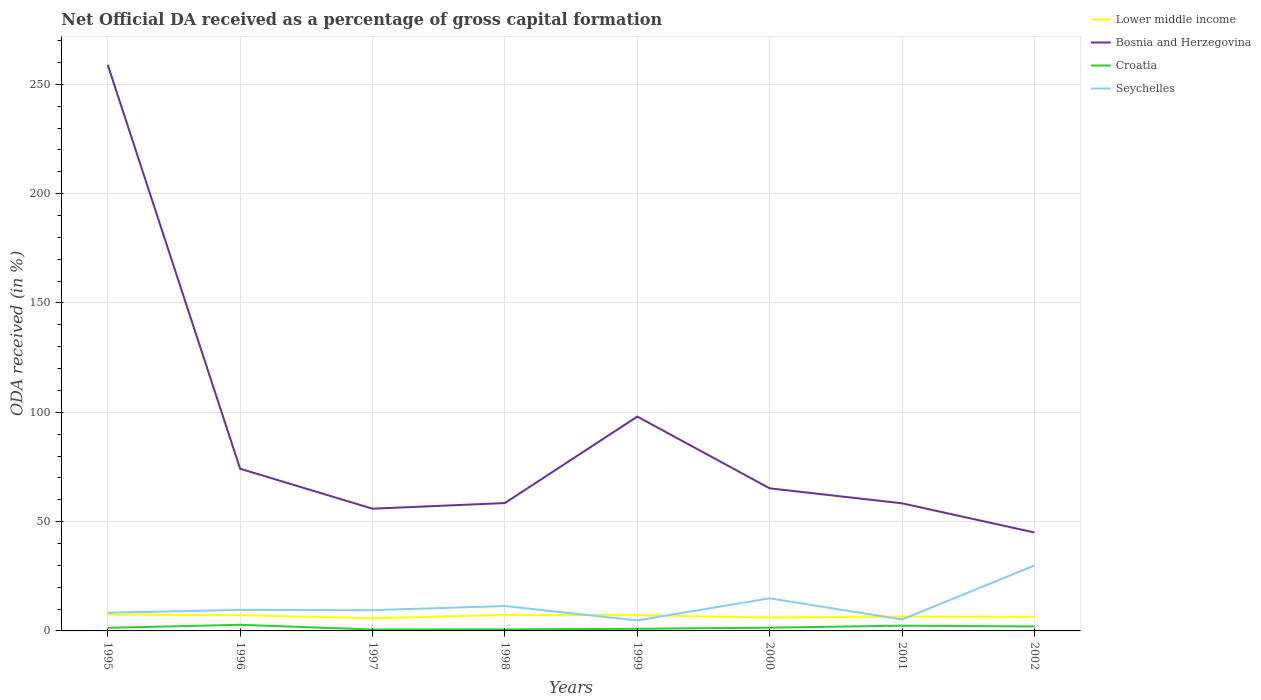Does the line corresponding to Croatia intersect with the line corresponding to Lower middle income?
Offer a terse response. No. Across all years, what is the maximum net ODA received in Bosnia and Herzegovina?
Offer a very short reply. 45.02. What is the total net ODA received in Seychelles in the graph?
Offer a very short reply. -24.7. What is the difference between the highest and the second highest net ODA received in Seychelles?
Keep it short and to the point. 25.13. What is the difference between the highest and the lowest net ODA received in Bosnia and Herzegovina?
Your answer should be very brief. 2. Is the net ODA received in Lower middle income strictly greater than the net ODA received in Seychelles over the years?
Give a very brief answer. No. Does the graph contain any zero values?
Ensure brevity in your answer.  No. Does the graph contain grids?
Provide a short and direct response. Yes. What is the title of the graph?
Provide a short and direct response. Net Official DA received as a percentage of gross capital formation. What is the label or title of the X-axis?
Make the answer very short. Years. What is the label or title of the Y-axis?
Make the answer very short. ODA received (in %). What is the ODA received (in %) of Lower middle income in 1995?
Provide a succinct answer. 7.51. What is the ODA received (in %) of Bosnia and Herzegovina in 1995?
Your response must be concise. 258.93. What is the ODA received (in %) in Croatia in 1995?
Ensure brevity in your answer.  1.41. What is the ODA received (in %) in Seychelles in 1995?
Your answer should be very brief. 8.32. What is the ODA received (in %) of Lower middle income in 1996?
Provide a succinct answer. 7.18. What is the ODA received (in %) in Bosnia and Herzegovina in 1996?
Offer a terse response. 74.18. What is the ODA received (in %) of Croatia in 1996?
Keep it short and to the point. 2.8. What is the ODA received (in %) of Seychelles in 1996?
Provide a short and direct response. 9.61. What is the ODA received (in %) in Lower middle income in 1997?
Provide a short and direct response. 5.78. What is the ODA received (in %) in Bosnia and Herzegovina in 1997?
Ensure brevity in your answer.  55.9. What is the ODA received (in %) in Croatia in 1997?
Give a very brief answer. 0.66. What is the ODA received (in %) of Seychelles in 1997?
Your answer should be very brief. 9.49. What is the ODA received (in %) of Lower middle income in 1998?
Offer a very short reply. 7.34. What is the ODA received (in %) in Bosnia and Herzegovina in 1998?
Provide a succinct answer. 58.49. What is the ODA received (in %) in Croatia in 1998?
Offer a very short reply. 0.72. What is the ODA received (in %) in Seychelles in 1998?
Your response must be concise. 11.38. What is the ODA received (in %) in Lower middle income in 1999?
Make the answer very short. 7.22. What is the ODA received (in %) of Bosnia and Herzegovina in 1999?
Offer a terse response. 98.04. What is the ODA received (in %) of Croatia in 1999?
Keep it short and to the point. 0.97. What is the ODA received (in %) of Seychelles in 1999?
Provide a short and direct response. 4.8. What is the ODA received (in %) of Lower middle income in 2000?
Your answer should be compact. 6.13. What is the ODA received (in %) of Bosnia and Herzegovina in 2000?
Your answer should be compact. 65.21. What is the ODA received (in %) in Croatia in 2000?
Keep it short and to the point. 1.49. What is the ODA received (in %) of Seychelles in 2000?
Offer a very short reply. 14.92. What is the ODA received (in %) of Lower middle income in 2001?
Offer a very short reply. 6.58. What is the ODA received (in %) of Bosnia and Herzegovina in 2001?
Ensure brevity in your answer.  58.36. What is the ODA received (in %) of Croatia in 2001?
Provide a short and direct response. 2.4. What is the ODA received (in %) of Seychelles in 2001?
Offer a very short reply. 5.23. What is the ODA received (in %) of Lower middle income in 2002?
Your answer should be compact. 6.42. What is the ODA received (in %) of Bosnia and Herzegovina in 2002?
Your response must be concise. 45.02. What is the ODA received (in %) of Croatia in 2002?
Keep it short and to the point. 2.05. What is the ODA received (in %) of Seychelles in 2002?
Your answer should be very brief. 29.92. Across all years, what is the maximum ODA received (in %) of Lower middle income?
Provide a short and direct response. 7.51. Across all years, what is the maximum ODA received (in %) in Bosnia and Herzegovina?
Provide a short and direct response. 258.93. Across all years, what is the maximum ODA received (in %) in Croatia?
Provide a short and direct response. 2.8. Across all years, what is the maximum ODA received (in %) in Seychelles?
Keep it short and to the point. 29.92. Across all years, what is the minimum ODA received (in %) in Lower middle income?
Offer a very short reply. 5.78. Across all years, what is the minimum ODA received (in %) of Bosnia and Herzegovina?
Offer a very short reply. 45.02. Across all years, what is the minimum ODA received (in %) in Croatia?
Your response must be concise. 0.66. Across all years, what is the minimum ODA received (in %) of Seychelles?
Keep it short and to the point. 4.8. What is the total ODA received (in %) in Lower middle income in the graph?
Provide a succinct answer. 54.15. What is the total ODA received (in %) in Bosnia and Herzegovina in the graph?
Give a very brief answer. 714.13. What is the total ODA received (in %) of Croatia in the graph?
Offer a terse response. 12.52. What is the total ODA received (in %) in Seychelles in the graph?
Your response must be concise. 93.67. What is the difference between the ODA received (in %) of Lower middle income in 1995 and that in 1996?
Ensure brevity in your answer.  0.32. What is the difference between the ODA received (in %) in Bosnia and Herzegovina in 1995 and that in 1996?
Your answer should be very brief. 184.74. What is the difference between the ODA received (in %) of Croatia in 1995 and that in 1996?
Your response must be concise. -1.39. What is the difference between the ODA received (in %) of Seychelles in 1995 and that in 1996?
Keep it short and to the point. -1.29. What is the difference between the ODA received (in %) of Lower middle income in 1995 and that in 1997?
Your response must be concise. 1.73. What is the difference between the ODA received (in %) in Bosnia and Herzegovina in 1995 and that in 1997?
Offer a very short reply. 203.03. What is the difference between the ODA received (in %) of Croatia in 1995 and that in 1997?
Give a very brief answer. 0.75. What is the difference between the ODA received (in %) of Seychelles in 1995 and that in 1997?
Your answer should be very brief. -1.17. What is the difference between the ODA received (in %) of Lower middle income in 1995 and that in 1998?
Ensure brevity in your answer.  0.17. What is the difference between the ODA received (in %) in Bosnia and Herzegovina in 1995 and that in 1998?
Ensure brevity in your answer.  200.44. What is the difference between the ODA received (in %) of Croatia in 1995 and that in 1998?
Keep it short and to the point. 0.7. What is the difference between the ODA received (in %) of Seychelles in 1995 and that in 1998?
Ensure brevity in your answer.  -3.06. What is the difference between the ODA received (in %) of Lower middle income in 1995 and that in 1999?
Provide a short and direct response. 0.29. What is the difference between the ODA received (in %) in Bosnia and Herzegovina in 1995 and that in 1999?
Your response must be concise. 160.89. What is the difference between the ODA received (in %) in Croatia in 1995 and that in 1999?
Offer a terse response. 0.44. What is the difference between the ODA received (in %) of Seychelles in 1995 and that in 1999?
Your answer should be very brief. 3.53. What is the difference between the ODA received (in %) of Lower middle income in 1995 and that in 2000?
Your answer should be compact. 1.38. What is the difference between the ODA received (in %) in Bosnia and Herzegovina in 1995 and that in 2000?
Make the answer very short. 193.71. What is the difference between the ODA received (in %) in Croatia in 1995 and that in 2000?
Make the answer very short. -0.08. What is the difference between the ODA received (in %) in Seychelles in 1995 and that in 2000?
Offer a terse response. -6.6. What is the difference between the ODA received (in %) in Lower middle income in 1995 and that in 2001?
Your response must be concise. 0.92. What is the difference between the ODA received (in %) in Bosnia and Herzegovina in 1995 and that in 2001?
Provide a short and direct response. 200.57. What is the difference between the ODA received (in %) in Croatia in 1995 and that in 2001?
Ensure brevity in your answer.  -0.99. What is the difference between the ODA received (in %) in Seychelles in 1995 and that in 2001?
Offer a very short reply. 3.09. What is the difference between the ODA received (in %) of Lower middle income in 1995 and that in 2002?
Keep it short and to the point. 1.09. What is the difference between the ODA received (in %) of Bosnia and Herzegovina in 1995 and that in 2002?
Ensure brevity in your answer.  213.91. What is the difference between the ODA received (in %) of Croatia in 1995 and that in 2002?
Provide a succinct answer. -0.64. What is the difference between the ODA received (in %) of Seychelles in 1995 and that in 2002?
Provide a short and direct response. -21.6. What is the difference between the ODA received (in %) in Lower middle income in 1996 and that in 1997?
Make the answer very short. 1.41. What is the difference between the ODA received (in %) in Bosnia and Herzegovina in 1996 and that in 1997?
Your response must be concise. 18.29. What is the difference between the ODA received (in %) in Croatia in 1996 and that in 1997?
Keep it short and to the point. 2.14. What is the difference between the ODA received (in %) in Seychelles in 1996 and that in 1997?
Make the answer very short. 0.12. What is the difference between the ODA received (in %) in Lower middle income in 1996 and that in 1998?
Ensure brevity in your answer.  -0.16. What is the difference between the ODA received (in %) of Bosnia and Herzegovina in 1996 and that in 1998?
Your answer should be compact. 15.7. What is the difference between the ODA received (in %) in Croatia in 1996 and that in 1998?
Provide a succinct answer. 2.08. What is the difference between the ODA received (in %) of Seychelles in 1996 and that in 1998?
Make the answer very short. -1.77. What is the difference between the ODA received (in %) in Lower middle income in 1996 and that in 1999?
Your answer should be very brief. -0.04. What is the difference between the ODA received (in %) of Bosnia and Herzegovina in 1996 and that in 1999?
Provide a short and direct response. -23.85. What is the difference between the ODA received (in %) in Croatia in 1996 and that in 1999?
Provide a short and direct response. 1.83. What is the difference between the ODA received (in %) of Seychelles in 1996 and that in 1999?
Make the answer very short. 4.82. What is the difference between the ODA received (in %) in Lower middle income in 1996 and that in 2000?
Keep it short and to the point. 1.05. What is the difference between the ODA received (in %) in Bosnia and Herzegovina in 1996 and that in 2000?
Your answer should be very brief. 8.97. What is the difference between the ODA received (in %) in Croatia in 1996 and that in 2000?
Give a very brief answer. 1.31. What is the difference between the ODA received (in %) of Seychelles in 1996 and that in 2000?
Offer a terse response. -5.31. What is the difference between the ODA received (in %) of Lower middle income in 1996 and that in 2001?
Ensure brevity in your answer.  0.6. What is the difference between the ODA received (in %) in Bosnia and Herzegovina in 1996 and that in 2001?
Make the answer very short. 15.82. What is the difference between the ODA received (in %) of Croatia in 1996 and that in 2001?
Your answer should be very brief. 0.4. What is the difference between the ODA received (in %) in Seychelles in 1996 and that in 2001?
Your answer should be compact. 4.38. What is the difference between the ODA received (in %) in Lower middle income in 1996 and that in 2002?
Your answer should be compact. 0.76. What is the difference between the ODA received (in %) of Bosnia and Herzegovina in 1996 and that in 2002?
Make the answer very short. 29.16. What is the difference between the ODA received (in %) of Croatia in 1996 and that in 2002?
Provide a short and direct response. 0.75. What is the difference between the ODA received (in %) of Seychelles in 1996 and that in 2002?
Offer a very short reply. -20.31. What is the difference between the ODA received (in %) in Lower middle income in 1997 and that in 1998?
Your answer should be compact. -1.56. What is the difference between the ODA received (in %) in Bosnia and Herzegovina in 1997 and that in 1998?
Offer a terse response. -2.59. What is the difference between the ODA received (in %) of Croatia in 1997 and that in 1998?
Make the answer very short. -0.06. What is the difference between the ODA received (in %) of Seychelles in 1997 and that in 1998?
Provide a short and direct response. -1.89. What is the difference between the ODA received (in %) in Lower middle income in 1997 and that in 1999?
Give a very brief answer. -1.44. What is the difference between the ODA received (in %) in Bosnia and Herzegovina in 1997 and that in 1999?
Your response must be concise. -42.14. What is the difference between the ODA received (in %) in Croatia in 1997 and that in 1999?
Ensure brevity in your answer.  -0.31. What is the difference between the ODA received (in %) in Seychelles in 1997 and that in 1999?
Keep it short and to the point. 4.7. What is the difference between the ODA received (in %) of Lower middle income in 1997 and that in 2000?
Your answer should be very brief. -0.35. What is the difference between the ODA received (in %) in Bosnia and Herzegovina in 1997 and that in 2000?
Offer a terse response. -9.32. What is the difference between the ODA received (in %) in Croatia in 1997 and that in 2000?
Give a very brief answer. -0.83. What is the difference between the ODA received (in %) in Seychelles in 1997 and that in 2000?
Ensure brevity in your answer.  -5.43. What is the difference between the ODA received (in %) of Lower middle income in 1997 and that in 2001?
Offer a very short reply. -0.81. What is the difference between the ODA received (in %) in Bosnia and Herzegovina in 1997 and that in 2001?
Your answer should be very brief. -2.46. What is the difference between the ODA received (in %) of Croatia in 1997 and that in 2001?
Make the answer very short. -1.74. What is the difference between the ODA received (in %) of Seychelles in 1997 and that in 2001?
Your answer should be compact. 4.26. What is the difference between the ODA received (in %) in Lower middle income in 1997 and that in 2002?
Give a very brief answer. -0.64. What is the difference between the ODA received (in %) in Bosnia and Herzegovina in 1997 and that in 2002?
Give a very brief answer. 10.88. What is the difference between the ODA received (in %) of Croatia in 1997 and that in 2002?
Ensure brevity in your answer.  -1.39. What is the difference between the ODA received (in %) of Seychelles in 1997 and that in 2002?
Keep it short and to the point. -20.43. What is the difference between the ODA received (in %) of Lower middle income in 1998 and that in 1999?
Provide a succinct answer. 0.12. What is the difference between the ODA received (in %) of Bosnia and Herzegovina in 1998 and that in 1999?
Provide a short and direct response. -39.55. What is the difference between the ODA received (in %) of Croatia in 1998 and that in 1999?
Ensure brevity in your answer.  -0.26. What is the difference between the ODA received (in %) of Seychelles in 1998 and that in 1999?
Ensure brevity in your answer.  6.59. What is the difference between the ODA received (in %) of Lower middle income in 1998 and that in 2000?
Provide a short and direct response. 1.21. What is the difference between the ODA received (in %) of Bosnia and Herzegovina in 1998 and that in 2000?
Your answer should be compact. -6.73. What is the difference between the ODA received (in %) of Croatia in 1998 and that in 2000?
Your answer should be very brief. -0.78. What is the difference between the ODA received (in %) of Seychelles in 1998 and that in 2000?
Give a very brief answer. -3.54. What is the difference between the ODA received (in %) in Lower middle income in 1998 and that in 2001?
Provide a succinct answer. 0.76. What is the difference between the ODA received (in %) of Bosnia and Herzegovina in 1998 and that in 2001?
Offer a terse response. 0.13. What is the difference between the ODA received (in %) of Croatia in 1998 and that in 2001?
Offer a terse response. -1.69. What is the difference between the ODA received (in %) of Seychelles in 1998 and that in 2001?
Keep it short and to the point. 6.15. What is the difference between the ODA received (in %) in Lower middle income in 1998 and that in 2002?
Give a very brief answer. 0.92. What is the difference between the ODA received (in %) in Bosnia and Herzegovina in 1998 and that in 2002?
Your answer should be very brief. 13.47. What is the difference between the ODA received (in %) of Croatia in 1998 and that in 2002?
Your answer should be very brief. -1.34. What is the difference between the ODA received (in %) of Seychelles in 1998 and that in 2002?
Give a very brief answer. -18.54. What is the difference between the ODA received (in %) of Lower middle income in 1999 and that in 2000?
Your answer should be compact. 1.09. What is the difference between the ODA received (in %) in Bosnia and Herzegovina in 1999 and that in 2000?
Provide a short and direct response. 32.82. What is the difference between the ODA received (in %) in Croatia in 1999 and that in 2000?
Your answer should be compact. -0.52. What is the difference between the ODA received (in %) in Seychelles in 1999 and that in 2000?
Provide a succinct answer. -10.12. What is the difference between the ODA received (in %) of Lower middle income in 1999 and that in 2001?
Your answer should be compact. 0.64. What is the difference between the ODA received (in %) in Bosnia and Herzegovina in 1999 and that in 2001?
Your answer should be compact. 39.68. What is the difference between the ODA received (in %) in Croatia in 1999 and that in 2001?
Provide a short and direct response. -1.43. What is the difference between the ODA received (in %) of Seychelles in 1999 and that in 2001?
Your answer should be compact. -0.43. What is the difference between the ODA received (in %) of Lower middle income in 1999 and that in 2002?
Offer a very short reply. 0.8. What is the difference between the ODA received (in %) in Bosnia and Herzegovina in 1999 and that in 2002?
Your response must be concise. 53.01. What is the difference between the ODA received (in %) in Croatia in 1999 and that in 2002?
Provide a short and direct response. -1.08. What is the difference between the ODA received (in %) in Seychelles in 1999 and that in 2002?
Give a very brief answer. -25.13. What is the difference between the ODA received (in %) of Lower middle income in 2000 and that in 2001?
Your answer should be very brief. -0.45. What is the difference between the ODA received (in %) of Bosnia and Herzegovina in 2000 and that in 2001?
Your response must be concise. 6.85. What is the difference between the ODA received (in %) of Croatia in 2000 and that in 2001?
Your response must be concise. -0.91. What is the difference between the ODA received (in %) in Seychelles in 2000 and that in 2001?
Offer a very short reply. 9.69. What is the difference between the ODA received (in %) of Lower middle income in 2000 and that in 2002?
Your answer should be compact. -0.29. What is the difference between the ODA received (in %) in Bosnia and Herzegovina in 2000 and that in 2002?
Give a very brief answer. 20.19. What is the difference between the ODA received (in %) in Croatia in 2000 and that in 2002?
Your response must be concise. -0.56. What is the difference between the ODA received (in %) in Seychelles in 2000 and that in 2002?
Offer a terse response. -15.01. What is the difference between the ODA received (in %) of Lower middle income in 2001 and that in 2002?
Give a very brief answer. 0.16. What is the difference between the ODA received (in %) in Bosnia and Herzegovina in 2001 and that in 2002?
Make the answer very short. 13.34. What is the difference between the ODA received (in %) in Croatia in 2001 and that in 2002?
Offer a very short reply. 0.35. What is the difference between the ODA received (in %) of Seychelles in 2001 and that in 2002?
Your answer should be compact. -24.7. What is the difference between the ODA received (in %) of Lower middle income in 1995 and the ODA received (in %) of Bosnia and Herzegovina in 1996?
Provide a succinct answer. -66.68. What is the difference between the ODA received (in %) in Lower middle income in 1995 and the ODA received (in %) in Croatia in 1996?
Give a very brief answer. 4.71. What is the difference between the ODA received (in %) of Lower middle income in 1995 and the ODA received (in %) of Seychelles in 1996?
Ensure brevity in your answer.  -2.11. What is the difference between the ODA received (in %) of Bosnia and Herzegovina in 1995 and the ODA received (in %) of Croatia in 1996?
Your response must be concise. 256.13. What is the difference between the ODA received (in %) of Bosnia and Herzegovina in 1995 and the ODA received (in %) of Seychelles in 1996?
Your answer should be very brief. 249.32. What is the difference between the ODA received (in %) in Croatia in 1995 and the ODA received (in %) in Seychelles in 1996?
Your answer should be very brief. -8.2. What is the difference between the ODA received (in %) of Lower middle income in 1995 and the ODA received (in %) of Bosnia and Herzegovina in 1997?
Ensure brevity in your answer.  -48.39. What is the difference between the ODA received (in %) in Lower middle income in 1995 and the ODA received (in %) in Croatia in 1997?
Offer a terse response. 6.85. What is the difference between the ODA received (in %) of Lower middle income in 1995 and the ODA received (in %) of Seychelles in 1997?
Your answer should be compact. -1.99. What is the difference between the ODA received (in %) of Bosnia and Herzegovina in 1995 and the ODA received (in %) of Croatia in 1997?
Your response must be concise. 258.27. What is the difference between the ODA received (in %) in Bosnia and Herzegovina in 1995 and the ODA received (in %) in Seychelles in 1997?
Provide a succinct answer. 249.44. What is the difference between the ODA received (in %) of Croatia in 1995 and the ODA received (in %) of Seychelles in 1997?
Keep it short and to the point. -8.08. What is the difference between the ODA received (in %) of Lower middle income in 1995 and the ODA received (in %) of Bosnia and Herzegovina in 1998?
Keep it short and to the point. -50.98. What is the difference between the ODA received (in %) in Lower middle income in 1995 and the ODA received (in %) in Croatia in 1998?
Offer a terse response. 6.79. What is the difference between the ODA received (in %) in Lower middle income in 1995 and the ODA received (in %) in Seychelles in 1998?
Provide a short and direct response. -3.87. What is the difference between the ODA received (in %) in Bosnia and Herzegovina in 1995 and the ODA received (in %) in Croatia in 1998?
Keep it short and to the point. 258.21. What is the difference between the ODA received (in %) of Bosnia and Herzegovina in 1995 and the ODA received (in %) of Seychelles in 1998?
Make the answer very short. 247.55. What is the difference between the ODA received (in %) of Croatia in 1995 and the ODA received (in %) of Seychelles in 1998?
Keep it short and to the point. -9.97. What is the difference between the ODA received (in %) of Lower middle income in 1995 and the ODA received (in %) of Bosnia and Herzegovina in 1999?
Make the answer very short. -90.53. What is the difference between the ODA received (in %) of Lower middle income in 1995 and the ODA received (in %) of Croatia in 1999?
Give a very brief answer. 6.53. What is the difference between the ODA received (in %) of Lower middle income in 1995 and the ODA received (in %) of Seychelles in 1999?
Make the answer very short. 2.71. What is the difference between the ODA received (in %) in Bosnia and Herzegovina in 1995 and the ODA received (in %) in Croatia in 1999?
Provide a succinct answer. 257.95. What is the difference between the ODA received (in %) of Bosnia and Herzegovina in 1995 and the ODA received (in %) of Seychelles in 1999?
Offer a terse response. 254.13. What is the difference between the ODA received (in %) of Croatia in 1995 and the ODA received (in %) of Seychelles in 1999?
Your answer should be compact. -3.38. What is the difference between the ODA received (in %) of Lower middle income in 1995 and the ODA received (in %) of Bosnia and Herzegovina in 2000?
Make the answer very short. -57.71. What is the difference between the ODA received (in %) in Lower middle income in 1995 and the ODA received (in %) in Croatia in 2000?
Offer a very short reply. 6.01. What is the difference between the ODA received (in %) in Lower middle income in 1995 and the ODA received (in %) in Seychelles in 2000?
Ensure brevity in your answer.  -7.41. What is the difference between the ODA received (in %) in Bosnia and Herzegovina in 1995 and the ODA received (in %) in Croatia in 2000?
Your answer should be very brief. 257.43. What is the difference between the ODA received (in %) in Bosnia and Herzegovina in 1995 and the ODA received (in %) in Seychelles in 2000?
Keep it short and to the point. 244.01. What is the difference between the ODA received (in %) in Croatia in 1995 and the ODA received (in %) in Seychelles in 2000?
Ensure brevity in your answer.  -13.51. What is the difference between the ODA received (in %) of Lower middle income in 1995 and the ODA received (in %) of Bosnia and Herzegovina in 2001?
Your answer should be compact. -50.85. What is the difference between the ODA received (in %) in Lower middle income in 1995 and the ODA received (in %) in Croatia in 2001?
Your answer should be compact. 5.1. What is the difference between the ODA received (in %) in Lower middle income in 1995 and the ODA received (in %) in Seychelles in 2001?
Offer a terse response. 2.28. What is the difference between the ODA received (in %) in Bosnia and Herzegovina in 1995 and the ODA received (in %) in Croatia in 2001?
Your answer should be very brief. 256.52. What is the difference between the ODA received (in %) in Bosnia and Herzegovina in 1995 and the ODA received (in %) in Seychelles in 2001?
Your response must be concise. 253.7. What is the difference between the ODA received (in %) in Croatia in 1995 and the ODA received (in %) in Seychelles in 2001?
Provide a succinct answer. -3.82. What is the difference between the ODA received (in %) of Lower middle income in 1995 and the ODA received (in %) of Bosnia and Herzegovina in 2002?
Make the answer very short. -37.52. What is the difference between the ODA received (in %) of Lower middle income in 1995 and the ODA received (in %) of Croatia in 2002?
Your response must be concise. 5.45. What is the difference between the ODA received (in %) in Lower middle income in 1995 and the ODA received (in %) in Seychelles in 2002?
Your answer should be very brief. -22.42. What is the difference between the ODA received (in %) of Bosnia and Herzegovina in 1995 and the ODA received (in %) of Croatia in 2002?
Give a very brief answer. 256.87. What is the difference between the ODA received (in %) in Bosnia and Herzegovina in 1995 and the ODA received (in %) in Seychelles in 2002?
Offer a very short reply. 229. What is the difference between the ODA received (in %) of Croatia in 1995 and the ODA received (in %) of Seychelles in 2002?
Make the answer very short. -28.51. What is the difference between the ODA received (in %) of Lower middle income in 1996 and the ODA received (in %) of Bosnia and Herzegovina in 1997?
Your answer should be very brief. -48.72. What is the difference between the ODA received (in %) of Lower middle income in 1996 and the ODA received (in %) of Croatia in 1997?
Give a very brief answer. 6.52. What is the difference between the ODA received (in %) of Lower middle income in 1996 and the ODA received (in %) of Seychelles in 1997?
Give a very brief answer. -2.31. What is the difference between the ODA received (in %) of Bosnia and Herzegovina in 1996 and the ODA received (in %) of Croatia in 1997?
Your answer should be very brief. 73.52. What is the difference between the ODA received (in %) in Bosnia and Herzegovina in 1996 and the ODA received (in %) in Seychelles in 1997?
Provide a short and direct response. 64.69. What is the difference between the ODA received (in %) of Croatia in 1996 and the ODA received (in %) of Seychelles in 1997?
Provide a short and direct response. -6.69. What is the difference between the ODA received (in %) of Lower middle income in 1996 and the ODA received (in %) of Bosnia and Herzegovina in 1998?
Your answer should be very brief. -51.31. What is the difference between the ODA received (in %) in Lower middle income in 1996 and the ODA received (in %) in Croatia in 1998?
Offer a very short reply. 6.47. What is the difference between the ODA received (in %) in Lower middle income in 1996 and the ODA received (in %) in Seychelles in 1998?
Ensure brevity in your answer.  -4.2. What is the difference between the ODA received (in %) of Bosnia and Herzegovina in 1996 and the ODA received (in %) of Croatia in 1998?
Keep it short and to the point. 73.47. What is the difference between the ODA received (in %) of Bosnia and Herzegovina in 1996 and the ODA received (in %) of Seychelles in 1998?
Offer a terse response. 62.8. What is the difference between the ODA received (in %) of Croatia in 1996 and the ODA received (in %) of Seychelles in 1998?
Your answer should be very brief. -8.58. What is the difference between the ODA received (in %) in Lower middle income in 1996 and the ODA received (in %) in Bosnia and Herzegovina in 1999?
Provide a short and direct response. -90.85. What is the difference between the ODA received (in %) of Lower middle income in 1996 and the ODA received (in %) of Croatia in 1999?
Your response must be concise. 6.21. What is the difference between the ODA received (in %) in Lower middle income in 1996 and the ODA received (in %) in Seychelles in 1999?
Your response must be concise. 2.39. What is the difference between the ODA received (in %) of Bosnia and Herzegovina in 1996 and the ODA received (in %) of Croatia in 1999?
Provide a short and direct response. 73.21. What is the difference between the ODA received (in %) in Bosnia and Herzegovina in 1996 and the ODA received (in %) in Seychelles in 1999?
Provide a succinct answer. 69.39. What is the difference between the ODA received (in %) in Croatia in 1996 and the ODA received (in %) in Seychelles in 1999?
Provide a succinct answer. -2. What is the difference between the ODA received (in %) in Lower middle income in 1996 and the ODA received (in %) in Bosnia and Herzegovina in 2000?
Provide a succinct answer. -58.03. What is the difference between the ODA received (in %) of Lower middle income in 1996 and the ODA received (in %) of Croatia in 2000?
Your response must be concise. 5.69. What is the difference between the ODA received (in %) in Lower middle income in 1996 and the ODA received (in %) in Seychelles in 2000?
Your response must be concise. -7.74. What is the difference between the ODA received (in %) of Bosnia and Herzegovina in 1996 and the ODA received (in %) of Croatia in 2000?
Make the answer very short. 72.69. What is the difference between the ODA received (in %) in Bosnia and Herzegovina in 1996 and the ODA received (in %) in Seychelles in 2000?
Give a very brief answer. 59.27. What is the difference between the ODA received (in %) of Croatia in 1996 and the ODA received (in %) of Seychelles in 2000?
Your answer should be compact. -12.12. What is the difference between the ODA received (in %) in Lower middle income in 1996 and the ODA received (in %) in Bosnia and Herzegovina in 2001?
Offer a very short reply. -51.18. What is the difference between the ODA received (in %) in Lower middle income in 1996 and the ODA received (in %) in Croatia in 2001?
Keep it short and to the point. 4.78. What is the difference between the ODA received (in %) of Lower middle income in 1996 and the ODA received (in %) of Seychelles in 2001?
Provide a short and direct response. 1.95. What is the difference between the ODA received (in %) of Bosnia and Herzegovina in 1996 and the ODA received (in %) of Croatia in 2001?
Your response must be concise. 71.78. What is the difference between the ODA received (in %) of Bosnia and Herzegovina in 1996 and the ODA received (in %) of Seychelles in 2001?
Your response must be concise. 68.95. What is the difference between the ODA received (in %) in Croatia in 1996 and the ODA received (in %) in Seychelles in 2001?
Your answer should be compact. -2.43. What is the difference between the ODA received (in %) in Lower middle income in 1996 and the ODA received (in %) in Bosnia and Herzegovina in 2002?
Provide a succinct answer. -37.84. What is the difference between the ODA received (in %) of Lower middle income in 1996 and the ODA received (in %) of Croatia in 2002?
Provide a succinct answer. 5.13. What is the difference between the ODA received (in %) of Lower middle income in 1996 and the ODA received (in %) of Seychelles in 2002?
Offer a very short reply. -22.74. What is the difference between the ODA received (in %) in Bosnia and Herzegovina in 1996 and the ODA received (in %) in Croatia in 2002?
Ensure brevity in your answer.  72.13. What is the difference between the ODA received (in %) of Bosnia and Herzegovina in 1996 and the ODA received (in %) of Seychelles in 2002?
Provide a succinct answer. 44.26. What is the difference between the ODA received (in %) in Croatia in 1996 and the ODA received (in %) in Seychelles in 2002?
Offer a very short reply. -27.12. What is the difference between the ODA received (in %) of Lower middle income in 1997 and the ODA received (in %) of Bosnia and Herzegovina in 1998?
Ensure brevity in your answer.  -52.71. What is the difference between the ODA received (in %) of Lower middle income in 1997 and the ODA received (in %) of Croatia in 1998?
Make the answer very short. 5.06. What is the difference between the ODA received (in %) in Lower middle income in 1997 and the ODA received (in %) in Seychelles in 1998?
Offer a terse response. -5.6. What is the difference between the ODA received (in %) of Bosnia and Herzegovina in 1997 and the ODA received (in %) of Croatia in 1998?
Provide a short and direct response. 55.18. What is the difference between the ODA received (in %) of Bosnia and Herzegovina in 1997 and the ODA received (in %) of Seychelles in 1998?
Offer a very short reply. 44.52. What is the difference between the ODA received (in %) in Croatia in 1997 and the ODA received (in %) in Seychelles in 1998?
Provide a succinct answer. -10.72. What is the difference between the ODA received (in %) in Lower middle income in 1997 and the ODA received (in %) in Bosnia and Herzegovina in 1999?
Give a very brief answer. -92.26. What is the difference between the ODA received (in %) of Lower middle income in 1997 and the ODA received (in %) of Croatia in 1999?
Offer a terse response. 4.8. What is the difference between the ODA received (in %) of Lower middle income in 1997 and the ODA received (in %) of Seychelles in 1999?
Provide a succinct answer. 0.98. What is the difference between the ODA received (in %) in Bosnia and Herzegovina in 1997 and the ODA received (in %) in Croatia in 1999?
Offer a terse response. 54.92. What is the difference between the ODA received (in %) in Bosnia and Herzegovina in 1997 and the ODA received (in %) in Seychelles in 1999?
Provide a succinct answer. 51.1. What is the difference between the ODA received (in %) in Croatia in 1997 and the ODA received (in %) in Seychelles in 1999?
Your response must be concise. -4.13. What is the difference between the ODA received (in %) of Lower middle income in 1997 and the ODA received (in %) of Bosnia and Herzegovina in 2000?
Offer a terse response. -59.44. What is the difference between the ODA received (in %) of Lower middle income in 1997 and the ODA received (in %) of Croatia in 2000?
Offer a very short reply. 4.28. What is the difference between the ODA received (in %) of Lower middle income in 1997 and the ODA received (in %) of Seychelles in 2000?
Make the answer very short. -9.14. What is the difference between the ODA received (in %) of Bosnia and Herzegovina in 1997 and the ODA received (in %) of Croatia in 2000?
Offer a very short reply. 54.41. What is the difference between the ODA received (in %) in Bosnia and Herzegovina in 1997 and the ODA received (in %) in Seychelles in 2000?
Your answer should be very brief. 40.98. What is the difference between the ODA received (in %) of Croatia in 1997 and the ODA received (in %) of Seychelles in 2000?
Provide a succinct answer. -14.26. What is the difference between the ODA received (in %) in Lower middle income in 1997 and the ODA received (in %) in Bosnia and Herzegovina in 2001?
Provide a short and direct response. -52.58. What is the difference between the ODA received (in %) of Lower middle income in 1997 and the ODA received (in %) of Croatia in 2001?
Offer a terse response. 3.37. What is the difference between the ODA received (in %) of Lower middle income in 1997 and the ODA received (in %) of Seychelles in 2001?
Provide a short and direct response. 0.55. What is the difference between the ODA received (in %) in Bosnia and Herzegovina in 1997 and the ODA received (in %) in Croatia in 2001?
Your answer should be very brief. 53.49. What is the difference between the ODA received (in %) in Bosnia and Herzegovina in 1997 and the ODA received (in %) in Seychelles in 2001?
Ensure brevity in your answer.  50.67. What is the difference between the ODA received (in %) of Croatia in 1997 and the ODA received (in %) of Seychelles in 2001?
Give a very brief answer. -4.57. What is the difference between the ODA received (in %) in Lower middle income in 1997 and the ODA received (in %) in Bosnia and Herzegovina in 2002?
Provide a short and direct response. -39.25. What is the difference between the ODA received (in %) of Lower middle income in 1997 and the ODA received (in %) of Croatia in 2002?
Give a very brief answer. 3.72. What is the difference between the ODA received (in %) in Lower middle income in 1997 and the ODA received (in %) in Seychelles in 2002?
Keep it short and to the point. -24.15. What is the difference between the ODA received (in %) in Bosnia and Herzegovina in 1997 and the ODA received (in %) in Croatia in 2002?
Your answer should be compact. 53.84. What is the difference between the ODA received (in %) in Bosnia and Herzegovina in 1997 and the ODA received (in %) in Seychelles in 2002?
Offer a very short reply. 25.97. What is the difference between the ODA received (in %) in Croatia in 1997 and the ODA received (in %) in Seychelles in 2002?
Give a very brief answer. -29.26. What is the difference between the ODA received (in %) of Lower middle income in 1998 and the ODA received (in %) of Bosnia and Herzegovina in 1999?
Your response must be concise. -90.7. What is the difference between the ODA received (in %) in Lower middle income in 1998 and the ODA received (in %) in Croatia in 1999?
Provide a short and direct response. 6.36. What is the difference between the ODA received (in %) of Lower middle income in 1998 and the ODA received (in %) of Seychelles in 1999?
Provide a succinct answer. 2.54. What is the difference between the ODA received (in %) in Bosnia and Herzegovina in 1998 and the ODA received (in %) in Croatia in 1999?
Give a very brief answer. 57.51. What is the difference between the ODA received (in %) of Bosnia and Herzegovina in 1998 and the ODA received (in %) of Seychelles in 1999?
Keep it short and to the point. 53.69. What is the difference between the ODA received (in %) in Croatia in 1998 and the ODA received (in %) in Seychelles in 1999?
Give a very brief answer. -4.08. What is the difference between the ODA received (in %) in Lower middle income in 1998 and the ODA received (in %) in Bosnia and Herzegovina in 2000?
Provide a succinct answer. -57.88. What is the difference between the ODA received (in %) of Lower middle income in 1998 and the ODA received (in %) of Croatia in 2000?
Ensure brevity in your answer.  5.85. What is the difference between the ODA received (in %) of Lower middle income in 1998 and the ODA received (in %) of Seychelles in 2000?
Offer a terse response. -7.58. What is the difference between the ODA received (in %) in Bosnia and Herzegovina in 1998 and the ODA received (in %) in Croatia in 2000?
Ensure brevity in your answer.  57. What is the difference between the ODA received (in %) of Bosnia and Herzegovina in 1998 and the ODA received (in %) of Seychelles in 2000?
Ensure brevity in your answer.  43.57. What is the difference between the ODA received (in %) of Croatia in 1998 and the ODA received (in %) of Seychelles in 2000?
Provide a succinct answer. -14.2. What is the difference between the ODA received (in %) of Lower middle income in 1998 and the ODA received (in %) of Bosnia and Herzegovina in 2001?
Your answer should be compact. -51.02. What is the difference between the ODA received (in %) of Lower middle income in 1998 and the ODA received (in %) of Croatia in 2001?
Your answer should be very brief. 4.93. What is the difference between the ODA received (in %) of Lower middle income in 1998 and the ODA received (in %) of Seychelles in 2001?
Your answer should be very brief. 2.11. What is the difference between the ODA received (in %) of Bosnia and Herzegovina in 1998 and the ODA received (in %) of Croatia in 2001?
Keep it short and to the point. 56.08. What is the difference between the ODA received (in %) in Bosnia and Herzegovina in 1998 and the ODA received (in %) in Seychelles in 2001?
Your answer should be compact. 53.26. What is the difference between the ODA received (in %) of Croatia in 1998 and the ODA received (in %) of Seychelles in 2001?
Offer a terse response. -4.51. What is the difference between the ODA received (in %) in Lower middle income in 1998 and the ODA received (in %) in Bosnia and Herzegovina in 2002?
Provide a short and direct response. -37.68. What is the difference between the ODA received (in %) in Lower middle income in 1998 and the ODA received (in %) in Croatia in 2002?
Your response must be concise. 5.28. What is the difference between the ODA received (in %) of Lower middle income in 1998 and the ODA received (in %) of Seychelles in 2002?
Provide a succinct answer. -22.59. What is the difference between the ODA received (in %) in Bosnia and Herzegovina in 1998 and the ODA received (in %) in Croatia in 2002?
Make the answer very short. 56.44. What is the difference between the ODA received (in %) of Bosnia and Herzegovina in 1998 and the ODA received (in %) of Seychelles in 2002?
Your answer should be very brief. 28.56. What is the difference between the ODA received (in %) of Croatia in 1998 and the ODA received (in %) of Seychelles in 2002?
Ensure brevity in your answer.  -29.21. What is the difference between the ODA received (in %) in Lower middle income in 1999 and the ODA received (in %) in Bosnia and Herzegovina in 2000?
Provide a short and direct response. -58. What is the difference between the ODA received (in %) in Lower middle income in 1999 and the ODA received (in %) in Croatia in 2000?
Offer a very short reply. 5.73. What is the difference between the ODA received (in %) of Lower middle income in 1999 and the ODA received (in %) of Seychelles in 2000?
Offer a very short reply. -7.7. What is the difference between the ODA received (in %) in Bosnia and Herzegovina in 1999 and the ODA received (in %) in Croatia in 2000?
Offer a terse response. 96.54. What is the difference between the ODA received (in %) in Bosnia and Herzegovina in 1999 and the ODA received (in %) in Seychelles in 2000?
Make the answer very short. 83.12. What is the difference between the ODA received (in %) in Croatia in 1999 and the ODA received (in %) in Seychelles in 2000?
Ensure brevity in your answer.  -13.94. What is the difference between the ODA received (in %) in Lower middle income in 1999 and the ODA received (in %) in Bosnia and Herzegovina in 2001?
Your answer should be very brief. -51.14. What is the difference between the ODA received (in %) in Lower middle income in 1999 and the ODA received (in %) in Croatia in 2001?
Your answer should be compact. 4.81. What is the difference between the ODA received (in %) of Lower middle income in 1999 and the ODA received (in %) of Seychelles in 2001?
Make the answer very short. 1.99. What is the difference between the ODA received (in %) of Bosnia and Herzegovina in 1999 and the ODA received (in %) of Croatia in 2001?
Provide a short and direct response. 95.63. What is the difference between the ODA received (in %) in Bosnia and Herzegovina in 1999 and the ODA received (in %) in Seychelles in 2001?
Keep it short and to the point. 92.81. What is the difference between the ODA received (in %) in Croatia in 1999 and the ODA received (in %) in Seychelles in 2001?
Your answer should be very brief. -4.25. What is the difference between the ODA received (in %) in Lower middle income in 1999 and the ODA received (in %) in Bosnia and Herzegovina in 2002?
Your answer should be compact. -37.8. What is the difference between the ODA received (in %) in Lower middle income in 1999 and the ODA received (in %) in Croatia in 2002?
Provide a short and direct response. 5.16. What is the difference between the ODA received (in %) of Lower middle income in 1999 and the ODA received (in %) of Seychelles in 2002?
Give a very brief answer. -22.71. What is the difference between the ODA received (in %) in Bosnia and Herzegovina in 1999 and the ODA received (in %) in Croatia in 2002?
Give a very brief answer. 95.98. What is the difference between the ODA received (in %) of Bosnia and Herzegovina in 1999 and the ODA received (in %) of Seychelles in 2002?
Ensure brevity in your answer.  68.11. What is the difference between the ODA received (in %) in Croatia in 1999 and the ODA received (in %) in Seychelles in 2002?
Provide a succinct answer. -28.95. What is the difference between the ODA received (in %) in Lower middle income in 2000 and the ODA received (in %) in Bosnia and Herzegovina in 2001?
Keep it short and to the point. -52.23. What is the difference between the ODA received (in %) in Lower middle income in 2000 and the ODA received (in %) in Croatia in 2001?
Your answer should be very brief. 3.72. What is the difference between the ODA received (in %) in Lower middle income in 2000 and the ODA received (in %) in Seychelles in 2001?
Keep it short and to the point. 0.9. What is the difference between the ODA received (in %) in Bosnia and Herzegovina in 2000 and the ODA received (in %) in Croatia in 2001?
Give a very brief answer. 62.81. What is the difference between the ODA received (in %) of Bosnia and Herzegovina in 2000 and the ODA received (in %) of Seychelles in 2001?
Your response must be concise. 59.98. What is the difference between the ODA received (in %) of Croatia in 2000 and the ODA received (in %) of Seychelles in 2001?
Make the answer very short. -3.74. What is the difference between the ODA received (in %) of Lower middle income in 2000 and the ODA received (in %) of Bosnia and Herzegovina in 2002?
Make the answer very short. -38.89. What is the difference between the ODA received (in %) in Lower middle income in 2000 and the ODA received (in %) in Croatia in 2002?
Provide a short and direct response. 4.07. What is the difference between the ODA received (in %) of Lower middle income in 2000 and the ODA received (in %) of Seychelles in 2002?
Ensure brevity in your answer.  -23.8. What is the difference between the ODA received (in %) of Bosnia and Herzegovina in 2000 and the ODA received (in %) of Croatia in 2002?
Your answer should be compact. 63.16. What is the difference between the ODA received (in %) of Bosnia and Herzegovina in 2000 and the ODA received (in %) of Seychelles in 2002?
Offer a terse response. 35.29. What is the difference between the ODA received (in %) of Croatia in 2000 and the ODA received (in %) of Seychelles in 2002?
Make the answer very short. -28.43. What is the difference between the ODA received (in %) of Lower middle income in 2001 and the ODA received (in %) of Bosnia and Herzegovina in 2002?
Ensure brevity in your answer.  -38.44. What is the difference between the ODA received (in %) in Lower middle income in 2001 and the ODA received (in %) in Croatia in 2002?
Make the answer very short. 4.53. What is the difference between the ODA received (in %) of Lower middle income in 2001 and the ODA received (in %) of Seychelles in 2002?
Your response must be concise. -23.34. What is the difference between the ODA received (in %) in Bosnia and Herzegovina in 2001 and the ODA received (in %) in Croatia in 2002?
Provide a short and direct response. 56.31. What is the difference between the ODA received (in %) of Bosnia and Herzegovina in 2001 and the ODA received (in %) of Seychelles in 2002?
Give a very brief answer. 28.44. What is the difference between the ODA received (in %) in Croatia in 2001 and the ODA received (in %) in Seychelles in 2002?
Your answer should be very brief. -27.52. What is the average ODA received (in %) in Lower middle income per year?
Make the answer very short. 6.77. What is the average ODA received (in %) in Bosnia and Herzegovina per year?
Make the answer very short. 89.27. What is the average ODA received (in %) of Croatia per year?
Keep it short and to the point. 1.56. What is the average ODA received (in %) of Seychelles per year?
Your answer should be very brief. 11.71. In the year 1995, what is the difference between the ODA received (in %) in Lower middle income and ODA received (in %) in Bosnia and Herzegovina?
Your answer should be compact. -251.42. In the year 1995, what is the difference between the ODA received (in %) of Lower middle income and ODA received (in %) of Croatia?
Provide a succinct answer. 6.09. In the year 1995, what is the difference between the ODA received (in %) in Lower middle income and ODA received (in %) in Seychelles?
Ensure brevity in your answer.  -0.82. In the year 1995, what is the difference between the ODA received (in %) in Bosnia and Herzegovina and ODA received (in %) in Croatia?
Give a very brief answer. 257.51. In the year 1995, what is the difference between the ODA received (in %) in Bosnia and Herzegovina and ODA received (in %) in Seychelles?
Provide a short and direct response. 250.61. In the year 1995, what is the difference between the ODA received (in %) in Croatia and ODA received (in %) in Seychelles?
Your response must be concise. -6.91. In the year 1996, what is the difference between the ODA received (in %) of Lower middle income and ODA received (in %) of Bosnia and Herzegovina?
Keep it short and to the point. -67. In the year 1996, what is the difference between the ODA received (in %) of Lower middle income and ODA received (in %) of Croatia?
Your answer should be compact. 4.38. In the year 1996, what is the difference between the ODA received (in %) in Lower middle income and ODA received (in %) in Seychelles?
Make the answer very short. -2.43. In the year 1996, what is the difference between the ODA received (in %) of Bosnia and Herzegovina and ODA received (in %) of Croatia?
Your answer should be very brief. 71.38. In the year 1996, what is the difference between the ODA received (in %) in Bosnia and Herzegovina and ODA received (in %) in Seychelles?
Make the answer very short. 64.57. In the year 1996, what is the difference between the ODA received (in %) in Croatia and ODA received (in %) in Seychelles?
Offer a terse response. -6.81. In the year 1997, what is the difference between the ODA received (in %) in Lower middle income and ODA received (in %) in Bosnia and Herzegovina?
Your answer should be compact. -50.12. In the year 1997, what is the difference between the ODA received (in %) in Lower middle income and ODA received (in %) in Croatia?
Provide a succinct answer. 5.12. In the year 1997, what is the difference between the ODA received (in %) of Lower middle income and ODA received (in %) of Seychelles?
Ensure brevity in your answer.  -3.71. In the year 1997, what is the difference between the ODA received (in %) in Bosnia and Herzegovina and ODA received (in %) in Croatia?
Your answer should be very brief. 55.24. In the year 1997, what is the difference between the ODA received (in %) of Bosnia and Herzegovina and ODA received (in %) of Seychelles?
Your response must be concise. 46.41. In the year 1997, what is the difference between the ODA received (in %) in Croatia and ODA received (in %) in Seychelles?
Give a very brief answer. -8.83. In the year 1998, what is the difference between the ODA received (in %) of Lower middle income and ODA received (in %) of Bosnia and Herzegovina?
Provide a succinct answer. -51.15. In the year 1998, what is the difference between the ODA received (in %) of Lower middle income and ODA received (in %) of Croatia?
Give a very brief answer. 6.62. In the year 1998, what is the difference between the ODA received (in %) in Lower middle income and ODA received (in %) in Seychelles?
Provide a short and direct response. -4.04. In the year 1998, what is the difference between the ODA received (in %) of Bosnia and Herzegovina and ODA received (in %) of Croatia?
Your answer should be compact. 57.77. In the year 1998, what is the difference between the ODA received (in %) of Bosnia and Herzegovina and ODA received (in %) of Seychelles?
Offer a very short reply. 47.11. In the year 1998, what is the difference between the ODA received (in %) of Croatia and ODA received (in %) of Seychelles?
Your answer should be compact. -10.66. In the year 1999, what is the difference between the ODA received (in %) of Lower middle income and ODA received (in %) of Bosnia and Herzegovina?
Provide a short and direct response. -90.82. In the year 1999, what is the difference between the ODA received (in %) in Lower middle income and ODA received (in %) in Croatia?
Ensure brevity in your answer.  6.24. In the year 1999, what is the difference between the ODA received (in %) in Lower middle income and ODA received (in %) in Seychelles?
Keep it short and to the point. 2.42. In the year 1999, what is the difference between the ODA received (in %) of Bosnia and Herzegovina and ODA received (in %) of Croatia?
Make the answer very short. 97.06. In the year 1999, what is the difference between the ODA received (in %) in Bosnia and Herzegovina and ODA received (in %) in Seychelles?
Your answer should be very brief. 93.24. In the year 1999, what is the difference between the ODA received (in %) of Croatia and ODA received (in %) of Seychelles?
Offer a terse response. -3.82. In the year 2000, what is the difference between the ODA received (in %) in Lower middle income and ODA received (in %) in Bosnia and Herzegovina?
Ensure brevity in your answer.  -59.09. In the year 2000, what is the difference between the ODA received (in %) in Lower middle income and ODA received (in %) in Croatia?
Offer a terse response. 4.63. In the year 2000, what is the difference between the ODA received (in %) of Lower middle income and ODA received (in %) of Seychelles?
Your answer should be compact. -8.79. In the year 2000, what is the difference between the ODA received (in %) in Bosnia and Herzegovina and ODA received (in %) in Croatia?
Give a very brief answer. 63.72. In the year 2000, what is the difference between the ODA received (in %) in Bosnia and Herzegovina and ODA received (in %) in Seychelles?
Your answer should be very brief. 50.3. In the year 2000, what is the difference between the ODA received (in %) of Croatia and ODA received (in %) of Seychelles?
Make the answer very short. -13.43. In the year 2001, what is the difference between the ODA received (in %) in Lower middle income and ODA received (in %) in Bosnia and Herzegovina?
Your answer should be very brief. -51.78. In the year 2001, what is the difference between the ODA received (in %) in Lower middle income and ODA received (in %) in Croatia?
Keep it short and to the point. 4.18. In the year 2001, what is the difference between the ODA received (in %) of Lower middle income and ODA received (in %) of Seychelles?
Your answer should be compact. 1.35. In the year 2001, what is the difference between the ODA received (in %) of Bosnia and Herzegovina and ODA received (in %) of Croatia?
Provide a succinct answer. 55.96. In the year 2001, what is the difference between the ODA received (in %) in Bosnia and Herzegovina and ODA received (in %) in Seychelles?
Provide a succinct answer. 53.13. In the year 2001, what is the difference between the ODA received (in %) of Croatia and ODA received (in %) of Seychelles?
Your response must be concise. -2.83. In the year 2002, what is the difference between the ODA received (in %) in Lower middle income and ODA received (in %) in Bosnia and Herzegovina?
Your answer should be compact. -38.6. In the year 2002, what is the difference between the ODA received (in %) of Lower middle income and ODA received (in %) of Croatia?
Keep it short and to the point. 4.37. In the year 2002, what is the difference between the ODA received (in %) in Lower middle income and ODA received (in %) in Seychelles?
Your answer should be very brief. -23.51. In the year 2002, what is the difference between the ODA received (in %) in Bosnia and Herzegovina and ODA received (in %) in Croatia?
Give a very brief answer. 42.97. In the year 2002, what is the difference between the ODA received (in %) of Bosnia and Herzegovina and ODA received (in %) of Seychelles?
Your answer should be compact. 15.1. In the year 2002, what is the difference between the ODA received (in %) of Croatia and ODA received (in %) of Seychelles?
Make the answer very short. -27.87. What is the ratio of the ODA received (in %) of Lower middle income in 1995 to that in 1996?
Offer a very short reply. 1.05. What is the ratio of the ODA received (in %) of Bosnia and Herzegovina in 1995 to that in 1996?
Keep it short and to the point. 3.49. What is the ratio of the ODA received (in %) in Croatia in 1995 to that in 1996?
Your response must be concise. 0.5. What is the ratio of the ODA received (in %) in Seychelles in 1995 to that in 1996?
Offer a very short reply. 0.87. What is the ratio of the ODA received (in %) of Lower middle income in 1995 to that in 1997?
Your answer should be compact. 1.3. What is the ratio of the ODA received (in %) in Bosnia and Herzegovina in 1995 to that in 1997?
Provide a succinct answer. 4.63. What is the ratio of the ODA received (in %) in Croatia in 1995 to that in 1997?
Offer a very short reply. 2.14. What is the ratio of the ODA received (in %) in Seychelles in 1995 to that in 1997?
Make the answer very short. 0.88. What is the ratio of the ODA received (in %) in Lower middle income in 1995 to that in 1998?
Ensure brevity in your answer.  1.02. What is the ratio of the ODA received (in %) in Bosnia and Herzegovina in 1995 to that in 1998?
Ensure brevity in your answer.  4.43. What is the ratio of the ODA received (in %) in Croatia in 1995 to that in 1998?
Offer a very short reply. 1.97. What is the ratio of the ODA received (in %) of Seychelles in 1995 to that in 1998?
Offer a very short reply. 0.73. What is the ratio of the ODA received (in %) in Lower middle income in 1995 to that in 1999?
Your answer should be compact. 1.04. What is the ratio of the ODA received (in %) of Bosnia and Herzegovina in 1995 to that in 1999?
Give a very brief answer. 2.64. What is the ratio of the ODA received (in %) in Croatia in 1995 to that in 1999?
Your response must be concise. 1.45. What is the ratio of the ODA received (in %) of Seychelles in 1995 to that in 1999?
Provide a succinct answer. 1.74. What is the ratio of the ODA received (in %) of Lower middle income in 1995 to that in 2000?
Ensure brevity in your answer.  1.22. What is the ratio of the ODA received (in %) in Bosnia and Herzegovina in 1995 to that in 2000?
Give a very brief answer. 3.97. What is the ratio of the ODA received (in %) in Croatia in 1995 to that in 2000?
Offer a very short reply. 0.95. What is the ratio of the ODA received (in %) of Seychelles in 1995 to that in 2000?
Make the answer very short. 0.56. What is the ratio of the ODA received (in %) in Lower middle income in 1995 to that in 2001?
Provide a succinct answer. 1.14. What is the ratio of the ODA received (in %) in Bosnia and Herzegovina in 1995 to that in 2001?
Your response must be concise. 4.44. What is the ratio of the ODA received (in %) in Croatia in 1995 to that in 2001?
Make the answer very short. 0.59. What is the ratio of the ODA received (in %) of Seychelles in 1995 to that in 2001?
Your answer should be compact. 1.59. What is the ratio of the ODA received (in %) of Lower middle income in 1995 to that in 2002?
Provide a succinct answer. 1.17. What is the ratio of the ODA received (in %) of Bosnia and Herzegovina in 1995 to that in 2002?
Provide a short and direct response. 5.75. What is the ratio of the ODA received (in %) in Croatia in 1995 to that in 2002?
Ensure brevity in your answer.  0.69. What is the ratio of the ODA received (in %) in Seychelles in 1995 to that in 2002?
Give a very brief answer. 0.28. What is the ratio of the ODA received (in %) in Lower middle income in 1996 to that in 1997?
Keep it short and to the point. 1.24. What is the ratio of the ODA received (in %) of Bosnia and Herzegovina in 1996 to that in 1997?
Offer a terse response. 1.33. What is the ratio of the ODA received (in %) of Croatia in 1996 to that in 1997?
Give a very brief answer. 4.24. What is the ratio of the ODA received (in %) of Seychelles in 1996 to that in 1997?
Keep it short and to the point. 1.01. What is the ratio of the ODA received (in %) in Lower middle income in 1996 to that in 1998?
Provide a short and direct response. 0.98. What is the ratio of the ODA received (in %) in Bosnia and Herzegovina in 1996 to that in 1998?
Make the answer very short. 1.27. What is the ratio of the ODA received (in %) of Croatia in 1996 to that in 1998?
Ensure brevity in your answer.  3.91. What is the ratio of the ODA received (in %) in Seychelles in 1996 to that in 1998?
Offer a terse response. 0.84. What is the ratio of the ODA received (in %) in Lower middle income in 1996 to that in 1999?
Make the answer very short. 0.99. What is the ratio of the ODA received (in %) of Bosnia and Herzegovina in 1996 to that in 1999?
Give a very brief answer. 0.76. What is the ratio of the ODA received (in %) in Croatia in 1996 to that in 1999?
Keep it short and to the point. 2.87. What is the ratio of the ODA received (in %) in Seychelles in 1996 to that in 1999?
Make the answer very short. 2. What is the ratio of the ODA received (in %) of Lower middle income in 1996 to that in 2000?
Give a very brief answer. 1.17. What is the ratio of the ODA received (in %) in Bosnia and Herzegovina in 1996 to that in 2000?
Keep it short and to the point. 1.14. What is the ratio of the ODA received (in %) of Croatia in 1996 to that in 2000?
Your response must be concise. 1.88. What is the ratio of the ODA received (in %) in Seychelles in 1996 to that in 2000?
Offer a terse response. 0.64. What is the ratio of the ODA received (in %) in Lower middle income in 1996 to that in 2001?
Your answer should be very brief. 1.09. What is the ratio of the ODA received (in %) of Bosnia and Herzegovina in 1996 to that in 2001?
Provide a short and direct response. 1.27. What is the ratio of the ODA received (in %) in Croatia in 1996 to that in 2001?
Keep it short and to the point. 1.16. What is the ratio of the ODA received (in %) in Seychelles in 1996 to that in 2001?
Keep it short and to the point. 1.84. What is the ratio of the ODA received (in %) in Lower middle income in 1996 to that in 2002?
Offer a very short reply. 1.12. What is the ratio of the ODA received (in %) of Bosnia and Herzegovina in 1996 to that in 2002?
Provide a short and direct response. 1.65. What is the ratio of the ODA received (in %) in Croatia in 1996 to that in 2002?
Your answer should be compact. 1.36. What is the ratio of the ODA received (in %) of Seychelles in 1996 to that in 2002?
Give a very brief answer. 0.32. What is the ratio of the ODA received (in %) of Lower middle income in 1997 to that in 1998?
Your response must be concise. 0.79. What is the ratio of the ODA received (in %) of Bosnia and Herzegovina in 1997 to that in 1998?
Your response must be concise. 0.96. What is the ratio of the ODA received (in %) in Croatia in 1997 to that in 1998?
Your answer should be very brief. 0.92. What is the ratio of the ODA received (in %) in Seychelles in 1997 to that in 1998?
Provide a succinct answer. 0.83. What is the ratio of the ODA received (in %) of Lower middle income in 1997 to that in 1999?
Your answer should be compact. 0.8. What is the ratio of the ODA received (in %) of Bosnia and Herzegovina in 1997 to that in 1999?
Offer a very short reply. 0.57. What is the ratio of the ODA received (in %) in Croatia in 1997 to that in 1999?
Your response must be concise. 0.68. What is the ratio of the ODA received (in %) of Seychelles in 1997 to that in 1999?
Offer a very short reply. 1.98. What is the ratio of the ODA received (in %) in Lower middle income in 1997 to that in 2000?
Your response must be concise. 0.94. What is the ratio of the ODA received (in %) of Bosnia and Herzegovina in 1997 to that in 2000?
Your answer should be compact. 0.86. What is the ratio of the ODA received (in %) in Croatia in 1997 to that in 2000?
Provide a succinct answer. 0.44. What is the ratio of the ODA received (in %) in Seychelles in 1997 to that in 2000?
Give a very brief answer. 0.64. What is the ratio of the ODA received (in %) of Lower middle income in 1997 to that in 2001?
Your answer should be very brief. 0.88. What is the ratio of the ODA received (in %) in Bosnia and Herzegovina in 1997 to that in 2001?
Offer a very short reply. 0.96. What is the ratio of the ODA received (in %) of Croatia in 1997 to that in 2001?
Offer a very short reply. 0.28. What is the ratio of the ODA received (in %) of Seychelles in 1997 to that in 2001?
Offer a very short reply. 1.82. What is the ratio of the ODA received (in %) of Lower middle income in 1997 to that in 2002?
Provide a succinct answer. 0.9. What is the ratio of the ODA received (in %) in Bosnia and Herzegovina in 1997 to that in 2002?
Make the answer very short. 1.24. What is the ratio of the ODA received (in %) of Croatia in 1997 to that in 2002?
Provide a succinct answer. 0.32. What is the ratio of the ODA received (in %) in Seychelles in 1997 to that in 2002?
Offer a very short reply. 0.32. What is the ratio of the ODA received (in %) of Lower middle income in 1998 to that in 1999?
Your answer should be very brief. 1.02. What is the ratio of the ODA received (in %) of Bosnia and Herzegovina in 1998 to that in 1999?
Provide a short and direct response. 0.6. What is the ratio of the ODA received (in %) of Croatia in 1998 to that in 1999?
Ensure brevity in your answer.  0.74. What is the ratio of the ODA received (in %) in Seychelles in 1998 to that in 1999?
Offer a terse response. 2.37. What is the ratio of the ODA received (in %) in Lower middle income in 1998 to that in 2000?
Offer a very short reply. 1.2. What is the ratio of the ODA received (in %) of Bosnia and Herzegovina in 1998 to that in 2000?
Your response must be concise. 0.9. What is the ratio of the ODA received (in %) in Croatia in 1998 to that in 2000?
Provide a short and direct response. 0.48. What is the ratio of the ODA received (in %) in Seychelles in 1998 to that in 2000?
Ensure brevity in your answer.  0.76. What is the ratio of the ODA received (in %) of Lower middle income in 1998 to that in 2001?
Offer a terse response. 1.11. What is the ratio of the ODA received (in %) of Croatia in 1998 to that in 2001?
Your response must be concise. 0.3. What is the ratio of the ODA received (in %) in Seychelles in 1998 to that in 2001?
Your response must be concise. 2.18. What is the ratio of the ODA received (in %) in Lower middle income in 1998 to that in 2002?
Provide a short and direct response. 1.14. What is the ratio of the ODA received (in %) of Bosnia and Herzegovina in 1998 to that in 2002?
Your answer should be compact. 1.3. What is the ratio of the ODA received (in %) of Croatia in 1998 to that in 2002?
Offer a very short reply. 0.35. What is the ratio of the ODA received (in %) of Seychelles in 1998 to that in 2002?
Provide a succinct answer. 0.38. What is the ratio of the ODA received (in %) in Lower middle income in 1999 to that in 2000?
Offer a terse response. 1.18. What is the ratio of the ODA received (in %) of Bosnia and Herzegovina in 1999 to that in 2000?
Ensure brevity in your answer.  1.5. What is the ratio of the ODA received (in %) of Croatia in 1999 to that in 2000?
Ensure brevity in your answer.  0.65. What is the ratio of the ODA received (in %) of Seychelles in 1999 to that in 2000?
Give a very brief answer. 0.32. What is the ratio of the ODA received (in %) in Lower middle income in 1999 to that in 2001?
Offer a very short reply. 1.1. What is the ratio of the ODA received (in %) of Bosnia and Herzegovina in 1999 to that in 2001?
Provide a succinct answer. 1.68. What is the ratio of the ODA received (in %) of Croatia in 1999 to that in 2001?
Give a very brief answer. 0.41. What is the ratio of the ODA received (in %) of Seychelles in 1999 to that in 2001?
Give a very brief answer. 0.92. What is the ratio of the ODA received (in %) of Lower middle income in 1999 to that in 2002?
Your response must be concise. 1.12. What is the ratio of the ODA received (in %) of Bosnia and Herzegovina in 1999 to that in 2002?
Ensure brevity in your answer.  2.18. What is the ratio of the ODA received (in %) in Croatia in 1999 to that in 2002?
Give a very brief answer. 0.47. What is the ratio of the ODA received (in %) of Seychelles in 1999 to that in 2002?
Keep it short and to the point. 0.16. What is the ratio of the ODA received (in %) in Lower middle income in 2000 to that in 2001?
Your response must be concise. 0.93. What is the ratio of the ODA received (in %) in Bosnia and Herzegovina in 2000 to that in 2001?
Ensure brevity in your answer.  1.12. What is the ratio of the ODA received (in %) in Croatia in 2000 to that in 2001?
Give a very brief answer. 0.62. What is the ratio of the ODA received (in %) in Seychelles in 2000 to that in 2001?
Ensure brevity in your answer.  2.85. What is the ratio of the ODA received (in %) in Lower middle income in 2000 to that in 2002?
Your answer should be very brief. 0.95. What is the ratio of the ODA received (in %) of Bosnia and Herzegovina in 2000 to that in 2002?
Your answer should be compact. 1.45. What is the ratio of the ODA received (in %) of Croatia in 2000 to that in 2002?
Make the answer very short. 0.73. What is the ratio of the ODA received (in %) in Seychelles in 2000 to that in 2002?
Offer a terse response. 0.5. What is the ratio of the ODA received (in %) in Lower middle income in 2001 to that in 2002?
Your answer should be very brief. 1.03. What is the ratio of the ODA received (in %) in Bosnia and Herzegovina in 2001 to that in 2002?
Your answer should be compact. 1.3. What is the ratio of the ODA received (in %) in Croatia in 2001 to that in 2002?
Keep it short and to the point. 1.17. What is the ratio of the ODA received (in %) in Seychelles in 2001 to that in 2002?
Provide a succinct answer. 0.17. What is the difference between the highest and the second highest ODA received (in %) in Lower middle income?
Your response must be concise. 0.17. What is the difference between the highest and the second highest ODA received (in %) of Bosnia and Herzegovina?
Give a very brief answer. 160.89. What is the difference between the highest and the second highest ODA received (in %) of Croatia?
Provide a succinct answer. 0.4. What is the difference between the highest and the second highest ODA received (in %) in Seychelles?
Give a very brief answer. 15.01. What is the difference between the highest and the lowest ODA received (in %) of Lower middle income?
Keep it short and to the point. 1.73. What is the difference between the highest and the lowest ODA received (in %) of Bosnia and Herzegovina?
Offer a terse response. 213.91. What is the difference between the highest and the lowest ODA received (in %) of Croatia?
Give a very brief answer. 2.14. What is the difference between the highest and the lowest ODA received (in %) in Seychelles?
Ensure brevity in your answer.  25.13. 